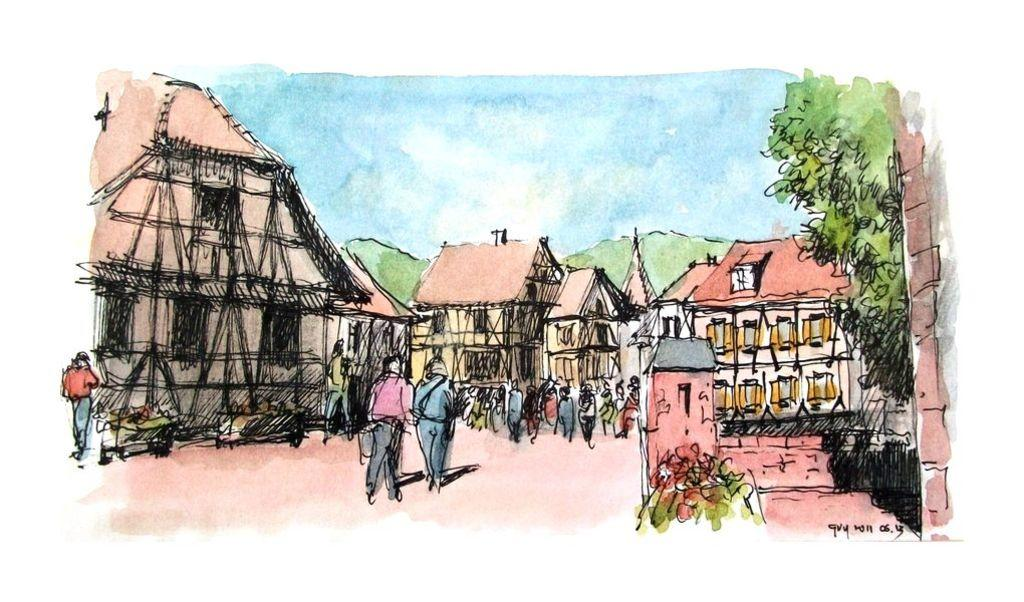What type of image is being described? The image is animated. What structures can be seen in the image? There are houses in the image. What are some people doing in the image? Some people are walking, and some are standing in the image. What can be seen in the background of the image? There are trees in the background of the image. Reasoning: Let's think step by breaking down the conversation step by step. We start by identifying the nature of the image, which is animated. Then, we describe the main structures present in the image, which are houses. Next, we focus on the actions of the people in the image, mentioning that some are walking and some are standing. Finally, we describe the background of the image, which includes trees. Absurd Question/Answer: What type of crayon can be seen in the hands of the people walking in the image? There are no crayons present in the image, and no one is holding a crayon. How many jellyfish are swimming in the background of the image? There are no jellyfish present in the image, as it features houses, people, and trees in the background. How does the ice cream move around in the image? The ice cream does not move around in the image; it is stationary in the bowl. 